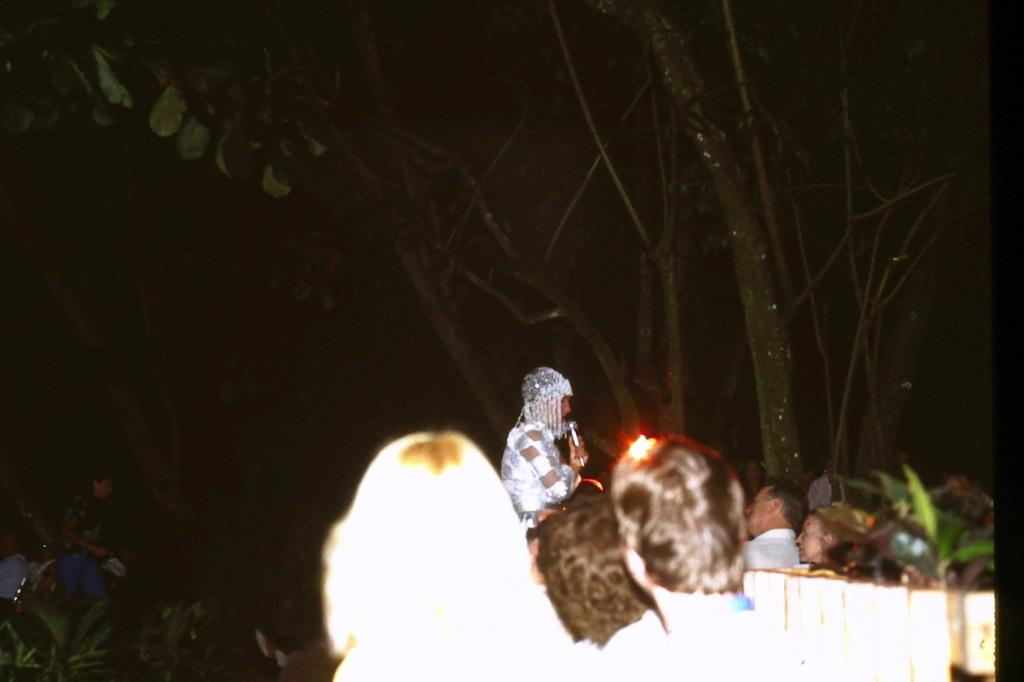How many persons are visible at the bottom of the image? There are persons at the bottom of the image, but the exact number is not specified. Can you describe the position of the person on the left side of the image? There is one person standing at the left side of the image. What is located at the top of the image? There is a tree at the top of the image. What type of comfort can be seen in the image? There is no reference to comfort in the image, so it cannot be determined from the image. How many bushes are present in the image? There is no mention of bushes in the image, so it cannot be determined from the image. 